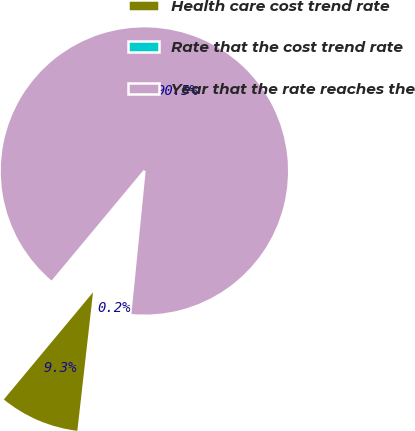Convert chart. <chart><loc_0><loc_0><loc_500><loc_500><pie_chart><fcel>Health care cost trend rate<fcel>Rate that the cost trend rate<fcel>Year that the rate reaches the<nl><fcel>9.25%<fcel>0.22%<fcel>90.52%<nl></chart> 